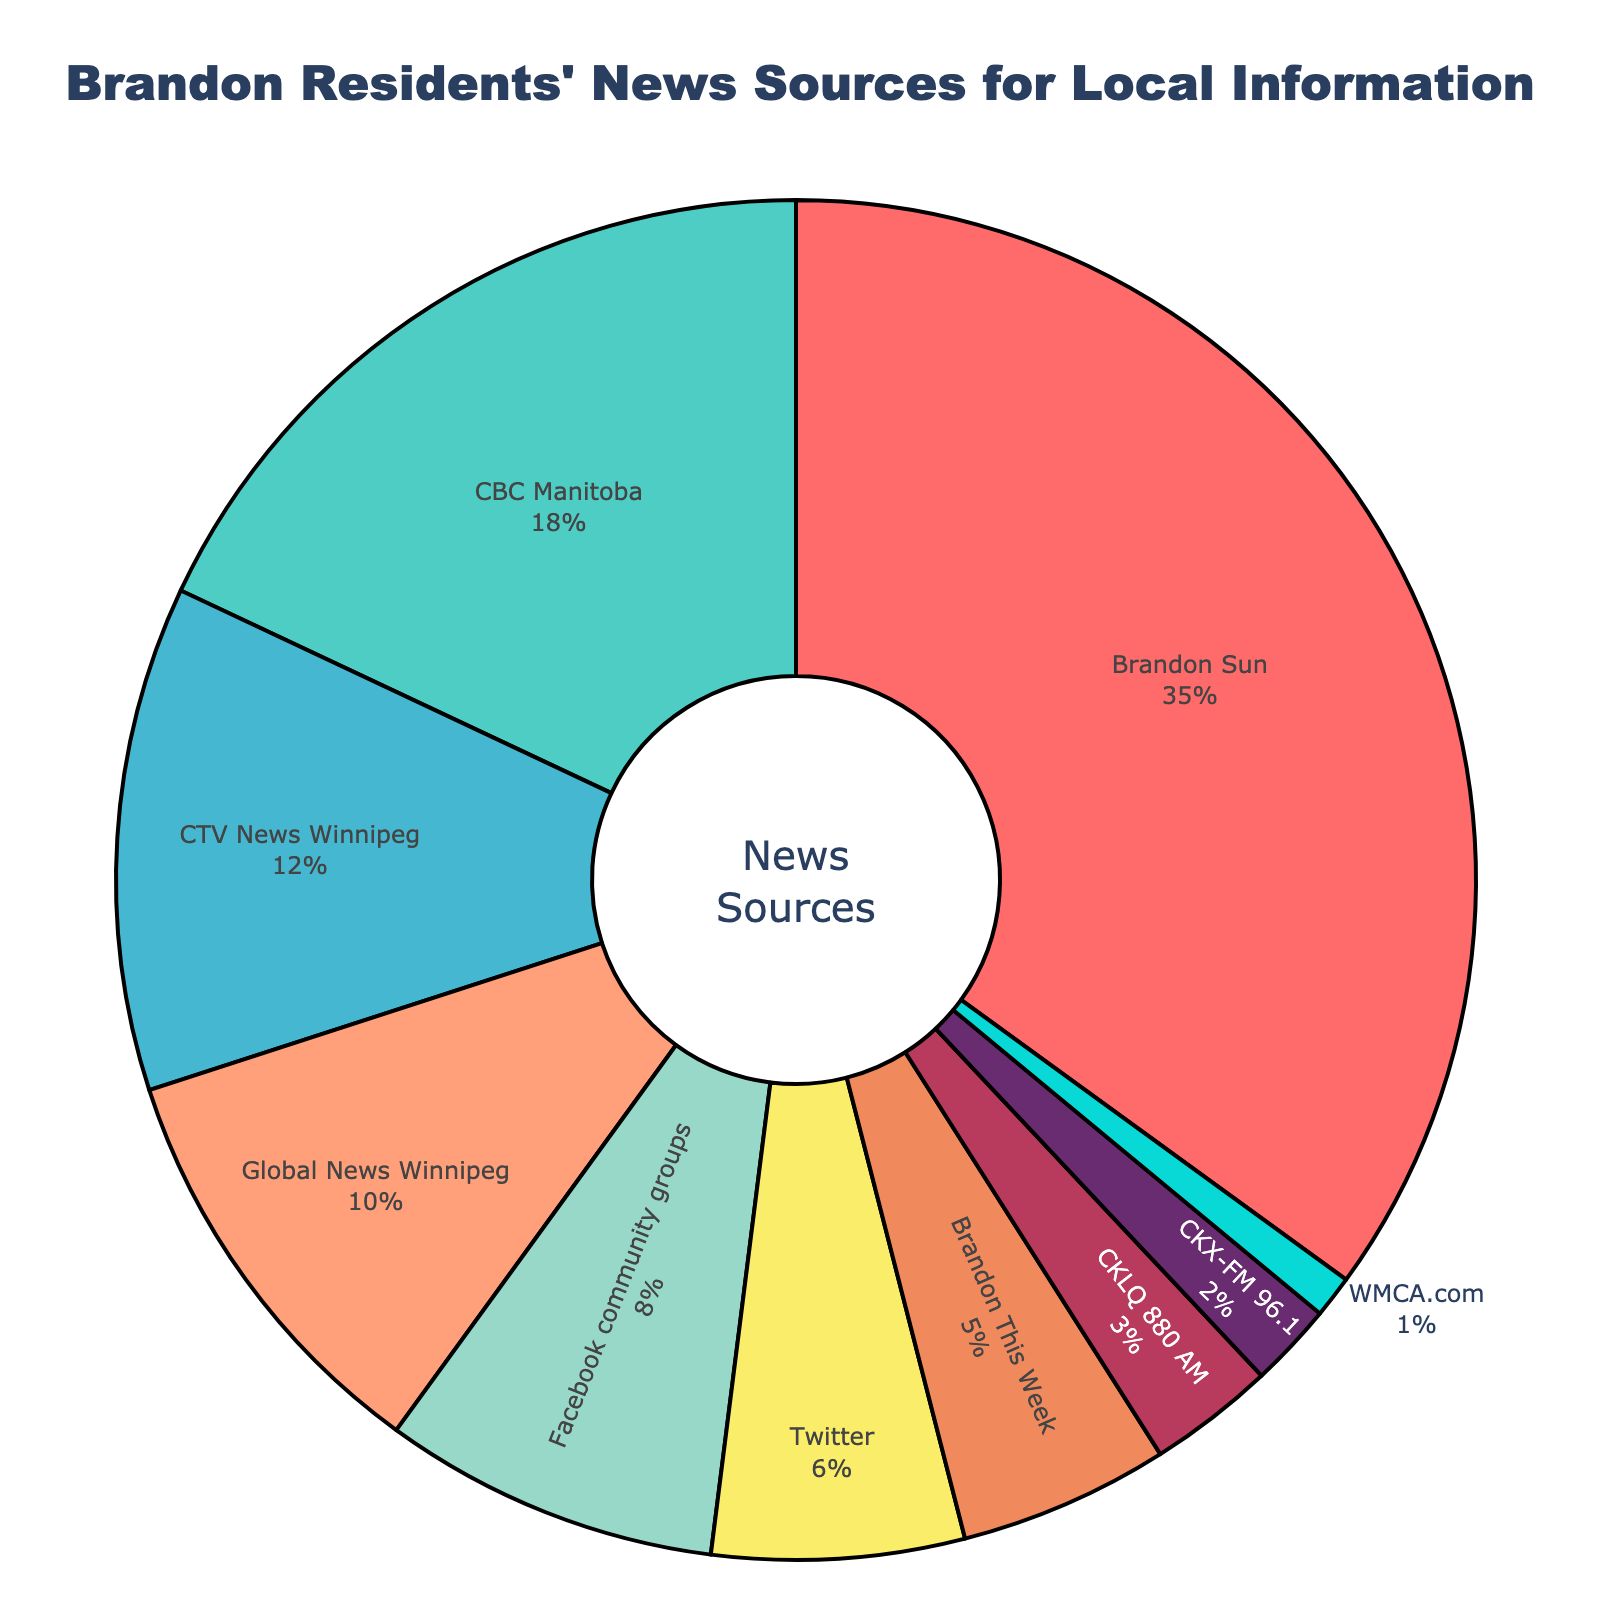What is the most popular news source for Brandon residents? The most popular news source can be identified by looking at the section of the pie chart with the largest percentage. In this case, the largest section corresponds to Brandon Sun with 35%.
Answer: Brandon Sun Which is more popular, CBC Manitoba or CTV News Winnipeg, and by how much? To find which is more popular and by how much, compare the percentages of CBC Manitoba and CTV News Winnipeg. CBC Manitoba has 18%, while CTV News Winnipeg has 12%. The difference is 18% - 12% = 6%.
Answer: CBC Manitoba, by 6% What percentage of the news sources are from social media (Facebook community groups and Twitter combined)? Add the percentages of Facebook community groups and Twitter. Facebook community groups have 8% and Twitter has 6%. Therefore, the combined percentage from social media is 8% + 6% = 14%.
Answer: 14% Which news sources have a single-digit percentage of 6% or less? Identify the segments of the pie chart with percentages of 6% or less. These are Twitter (6%), Brandon This Week (5%), CKLQ 880 AM (3%), CKX-FM 96.1 (2%), and WMCA.com (1%).
Answer: Twitter, Brandon This Week, CKLQ 880 AM, CKX-FM 96.1, WMCA.com How much more popular is Brandon Sun compared to CTV News Winnipeg? Compare the percentages of Brandon Sun and CTV News Winnipeg. Brandon Sun has 35%, and CTV News Winnipeg has 12%. The difference is 35% - 12% = 23%.
Answer: 23% more What is the total percentage of news sources based in Winnipeg (CBC Manitoba, CTV News Winnipeg, Global News Winnipeg)? Add the percentages of CBC Manitoba, CTV News Winnipeg, and Global News Winnipeg. CBC Manitoba has 18%, CTV News Winnipeg has 12%, and Global News Winnipeg has 10%. Therefore, the total is 18% + 12% + 10% = 40%.
Answer: 40% Which source has the smallest percentage, and what is it? Identify the smallest section in the pie chart which corresponds to WMCA.com with 1%.
Answer: WMCA.com, 1% How do the combined percentages of Global News Winnipeg and CTV News Winnipeg compare to Brandon Sun? Add the percentages of Global News Winnipeg and CTV News Winnipeg, then compare this total to Brandon Sun. Global News Winnipeg is 10%, and CTV News Winnipeg is 12%, so their combined percentage is 10% + 12% = 22%. Brandon Sun has 35%, which is larger than 22%.
Answer: Brandon Sun is larger by 13% What is the second most popular news source? After identifying the most popular news source (Brandon Sun), look for the next largest segment. The second largest segment is CBC Manitoba with 18%.
Answer: CBC Manitoba What percentage of residents use CKLQ 880 AM and CKX-FM 96.1 combined? Add the percentages of CKLQ 880 AM and CKX-FM 96.1. CKLQ 880 AM has 3% and CKX-FM 96.1 has 2%. Therefore, their combined percentage is 3% + 2% = 5%.
Answer: 5% 